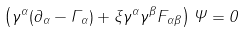<formula> <loc_0><loc_0><loc_500><loc_500>\left ( \gamma ^ { \alpha } ( \partial _ { \alpha } - \Gamma _ { \alpha } ) + \xi \gamma ^ { \alpha } \gamma ^ { \beta } F _ { \alpha \beta } \right ) \Psi = 0</formula> 